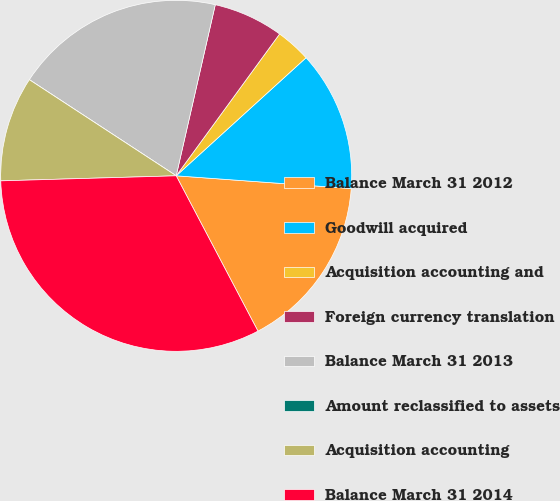Convert chart. <chart><loc_0><loc_0><loc_500><loc_500><pie_chart><fcel>Balance March 31 2012<fcel>Goodwill acquired<fcel>Acquisition accounting and<fcel>Foreign currency translation<fcel>Balance March 31 2013<fcel>Amount reclassified to assets<fcel>Acquisition accounting<fcel>Balance March 31 2014<nl><fcel>16.13%<fcel>12.9%<fcel>3.23%<fcel>6.45%<fcel>19.35%<fcel>0.0%<fcel>9.68%<fcel>32.25%<nl></chart> 